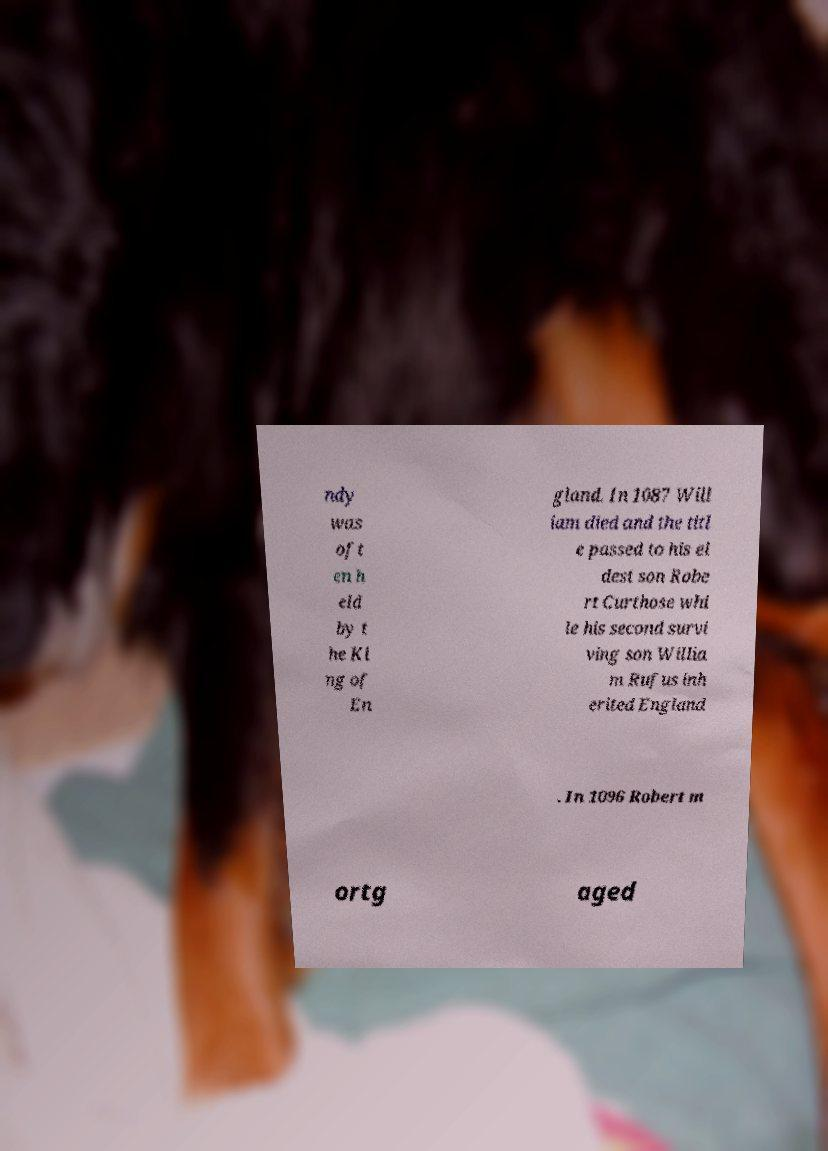For documentation purposes, I need the text within this image transcribed. Could you provide that? ndy was oft en h eld by t he Ki ng of En gland. In 1087 Will iam died and the titl e passed to his el dest son Robe rt Curthose whi le his second survi ving son Willia m Rufus inh erited England . In 1096 Robert m ortg aged 